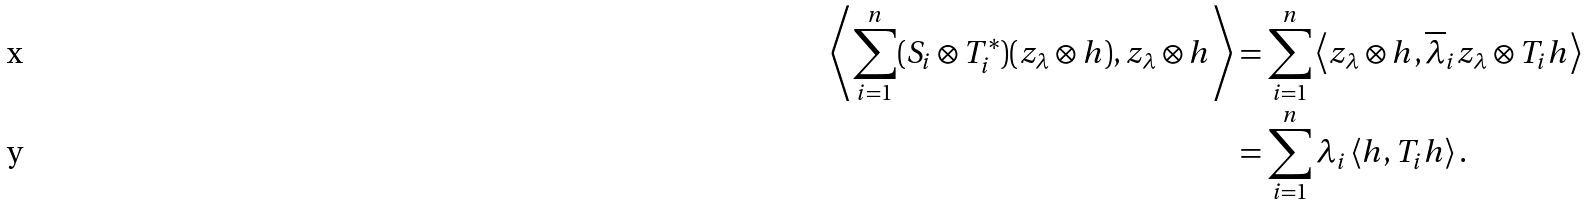<formula> <loc_0><loc_0><loc_500><loc_500>\left < \sum _ { i = 1 } ^ { n } ( S _ { i } \otimes T _ { i } ^ { * } ) ( z _ { \lambda } \otimes h ) , z _ { \lambda } \otimes h \right > & = \sum _ { i = 1 } ^ { n } \left < z _ { \lambda } \otimes h , \overline { \lambda } _ { i } z _ { \lambda } \otimes T _ { i } h \right > \\ & = \sum _ { i = 1 } ^ { n } \lambda _ { i } \left < h , T _ { i } h \right > .</formula> 